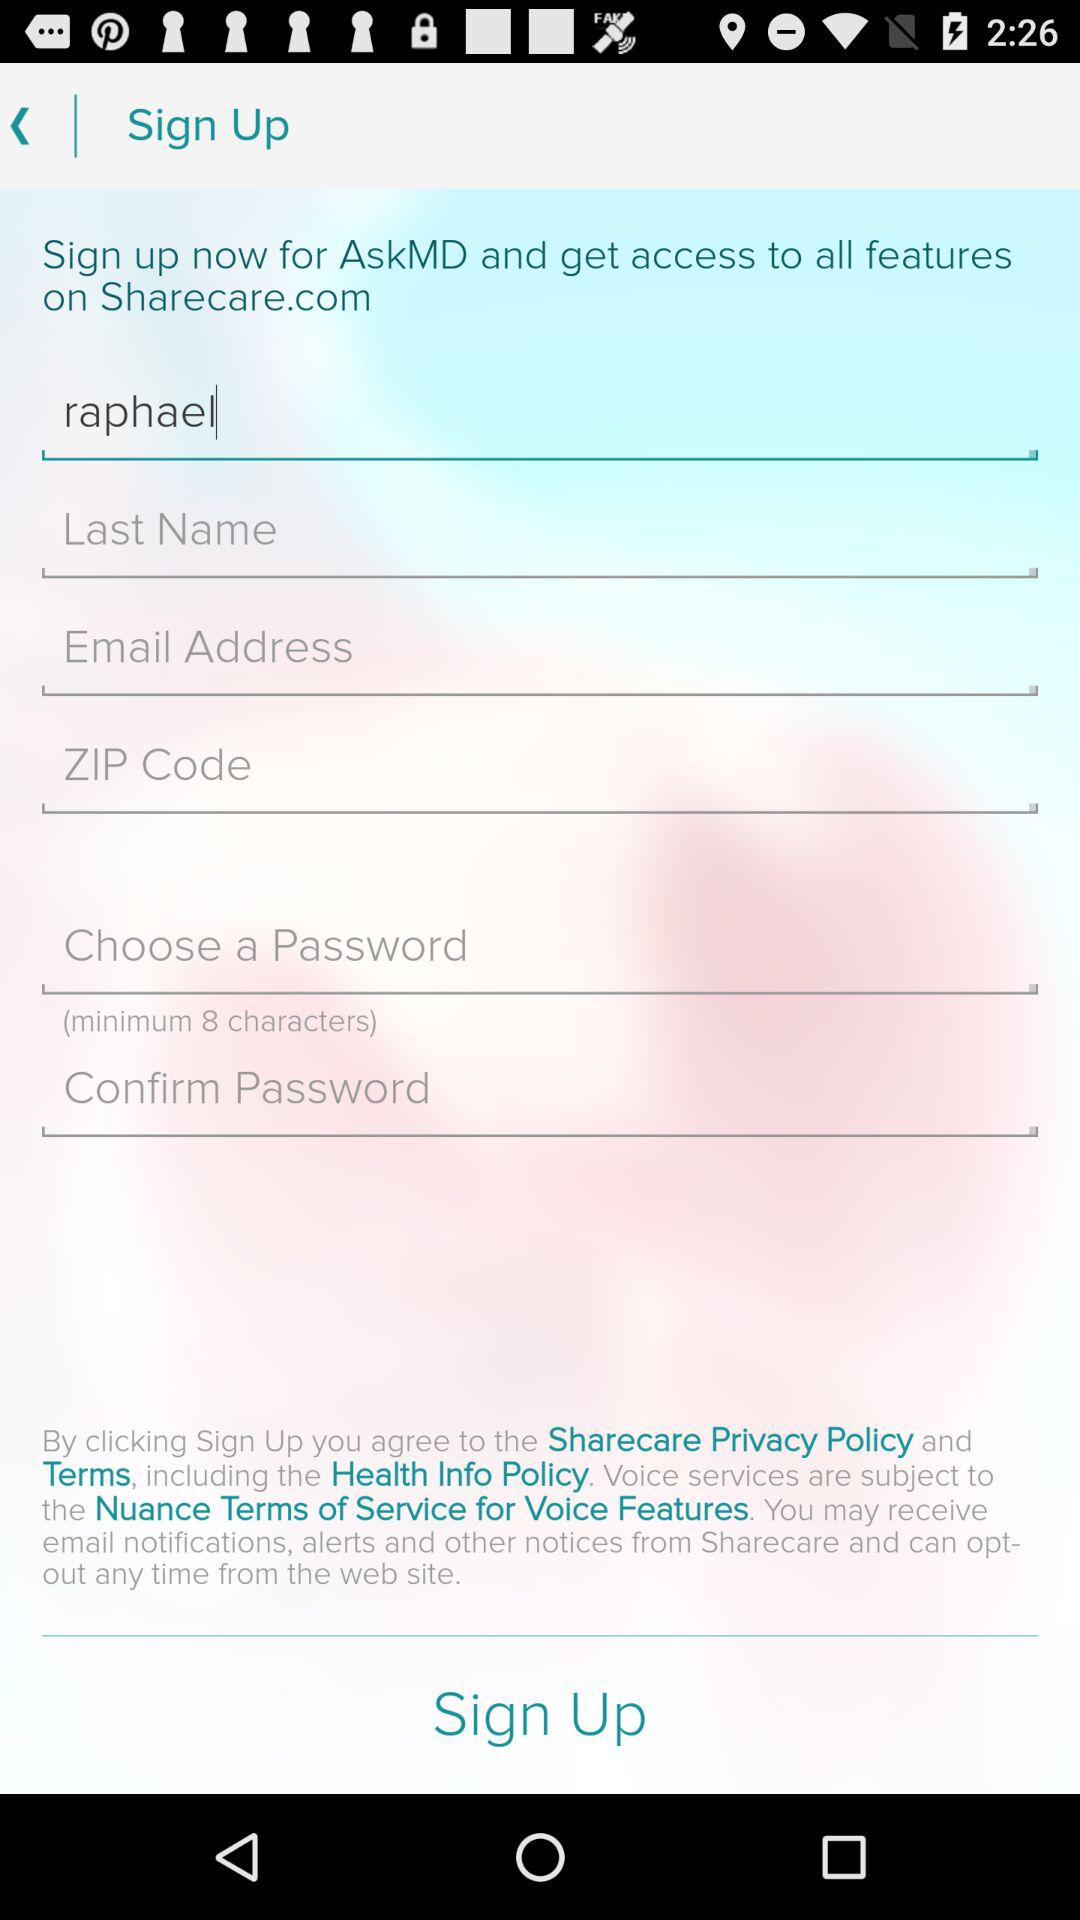What is the name of the user? The name of the user is Raphael. 